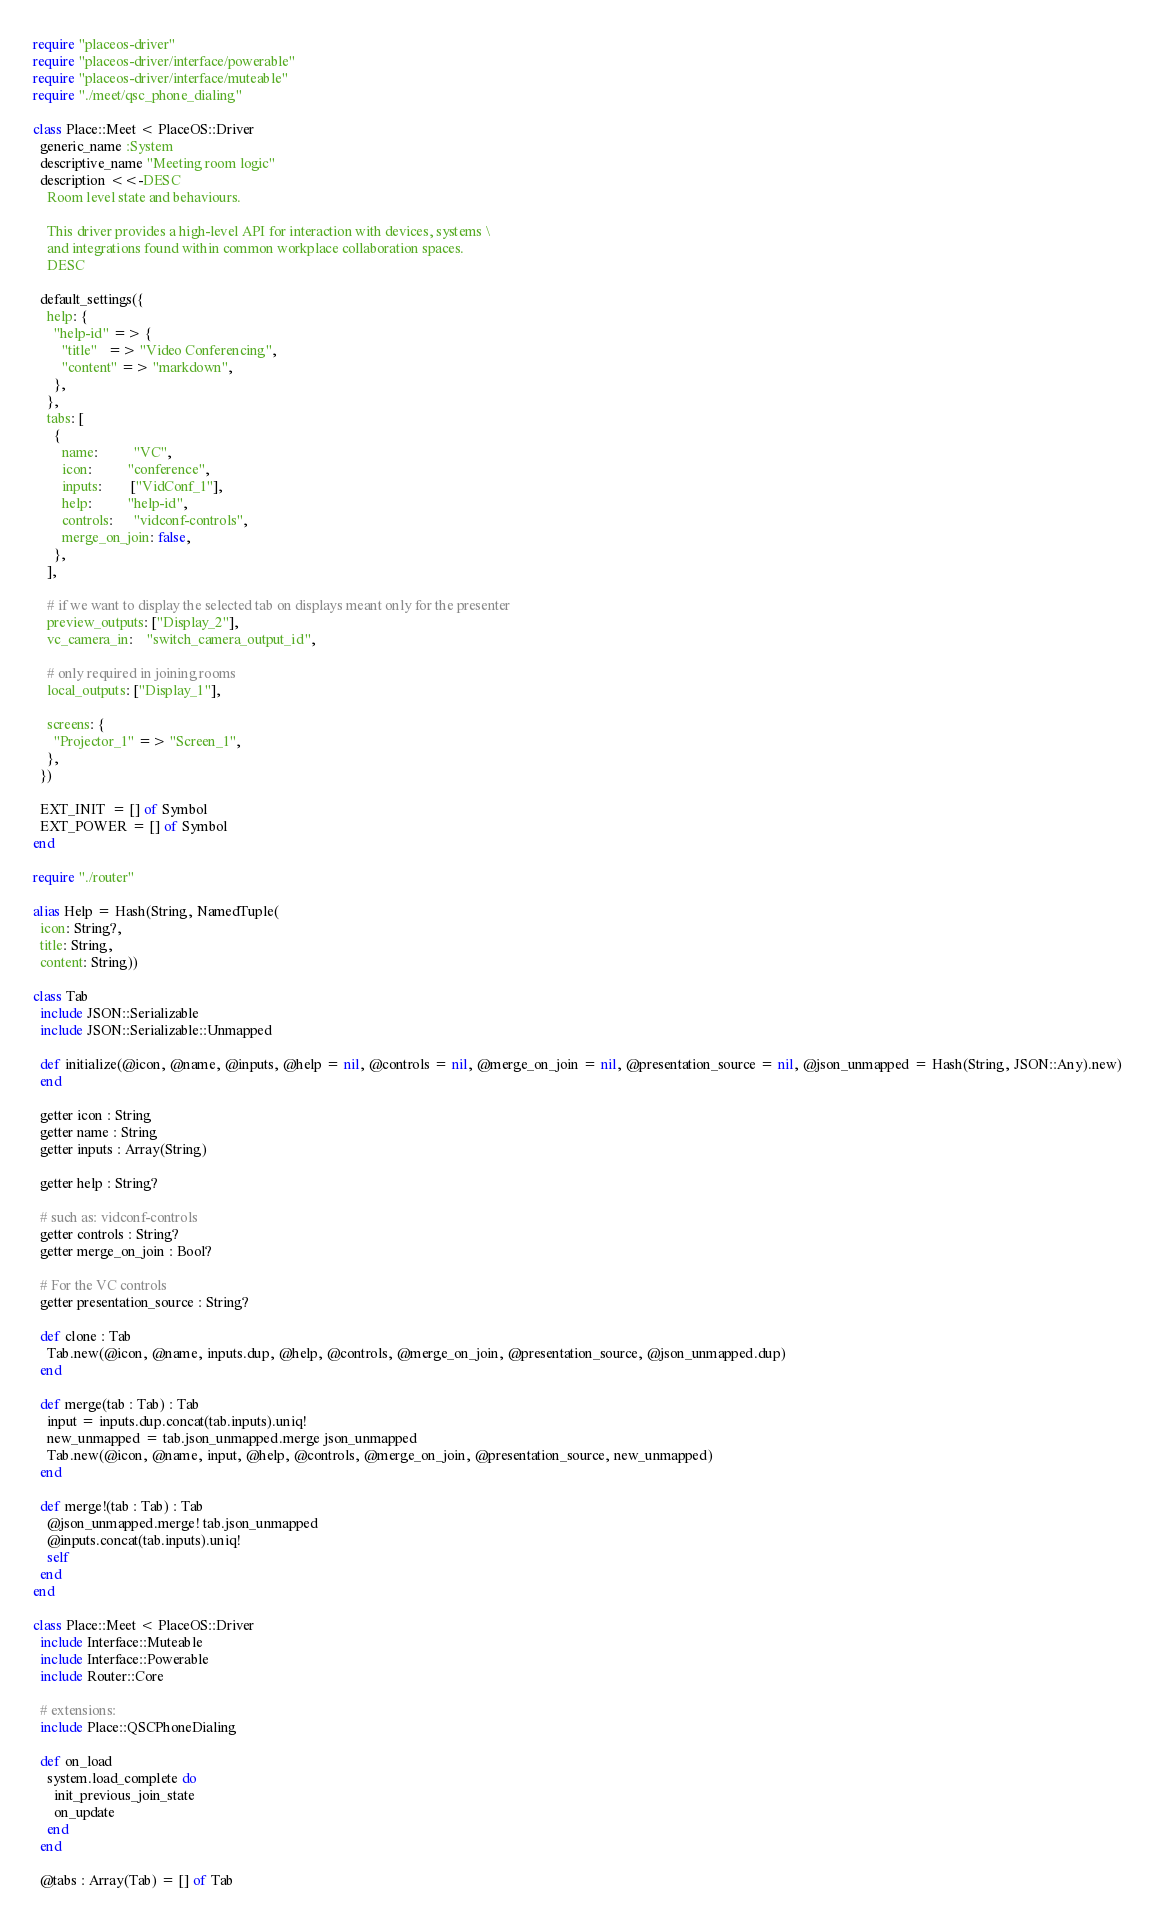Convert code to text. <code><loc_0><loc_0><loc_500><loc_500><_Crystal_>require "placeos-driver"
require "placeos-driver/interface/powerable"
require "placeos-driver/interface/muteable"
require "./meet/qsc_phone_dialing"

class Place::Meet < PlaceOS::Driver
  generic_name :System
  descriptive_name "Meeting room logic"
  description <<-DESC
    Room level state and behaviours.

    This driver provides a high-level API for interaction with devices, systems \
    and integrations found within common workplace collaboration spaces.
    DESC

  default_settings({
    help: {
      "help-id" => {
        "title"   => "Video Conferencing",
        "content" => "markdown",
      },
    },
    tabs: [
      {
        name:          "VC",
        icon:          "conference",
        inputs:        ["VidConf_1"],
        help:          "help-id",
        controls:      "vidconf-controls",
        merge_on_join: false,
      },
    ],

    # if we want to display the selected tab on displays meant only for the presenter
    preview_outputs: ["Display_2"],
    vc_camera_in:    "switch_camera_output_id",

    # only required in joining rooms
    local_outputs: ["Display_1"],

    screens: {
      "Projector_1" => "Screen_1",
    },
  })

  EXT_INIT  = [] of Symbol
  EXT_POWER = [] of Symbol
end

require "./router"

alias Help = Hash(String, NamedTuple(
  icon: String?,
  title: String,
  content: String))

class Tab
  include JSON::Serializable
  include JSON::Serializable::Unmapped

  def initialize(@icon, @name, @inputs, @help = nil, @controls = nil, @merge_on_join = nil, @presentation_source = nil, @json_unmapped = Hash(String, JSON::Any).new)
  end

  getter icon : String
  getter name : String
  getter inputs : Array(String)

  getter help : String?

  # such as: vidconf-controls
  getter controls : String?
  getter merge_on_join : Bool?

  # For the VC controls
  getter presentation_source : String?

  def clone : Tab
    Tab.new(@icon, @name, inputs.dup, @help, @controls, @merge_on_join, @presentation_source, @json_unmapped.dup)
  end

  def merge(tab : Tab) : Tab
    input = inputs.dup.concat(tab.inputs).uniq!
    new_unmapped = tab.json_unmapped.merge json_unmapped
    Tab.new(@icon, @name, input, @help, @controls, @merge_on_join, @presentation_source, new_unmapped)
  end

  def merge!(tab : Tab) : Tab
    @json_unmapped.merge! tab.json_unmapped
    @inputs.concat(tab.inputs).uniq!
    self
  end
end

class Place::Meet < PlaceOS::Driver
  include Interface::Muteable
  include Interface::Powerable
  include Router::Core

  # extensions:
  include Place::QSCPhoneDialing

  def on_load
    system.load_complete do
      init_previous_join_state
      on_update
    end
  end

  @tabs : Array(Tab) = [] of Tab</code> 